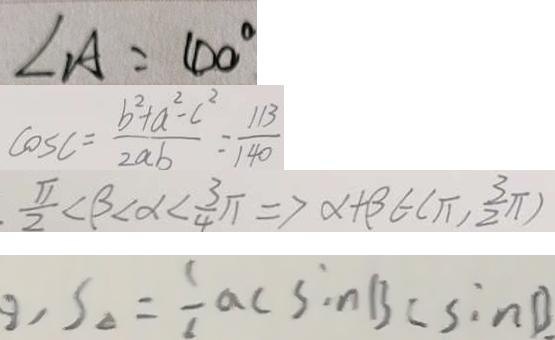<formula> <loc_0><loc_0><loc_500><loc_500>\angle A = 4 0 ^ { \circ } 
 \cos C = \frac { b ^ { 2 } + a ^ { 2 } - c ^ { 2 } } { 2 a b } = \frac { 1 1 3 } { 1 4 0 } 
 . \frac { \pi } { 2 } < \beta < \alpha < \frac { 3 } { 4 } \pi \Rightarrow \alpha + \beta \in ( \pi , \frac { 3 } { 2 } \pi ) 
 , S _ { \Delta } = \frac { 1 } { 6 } a c \sin B c \sin B .</formula> 